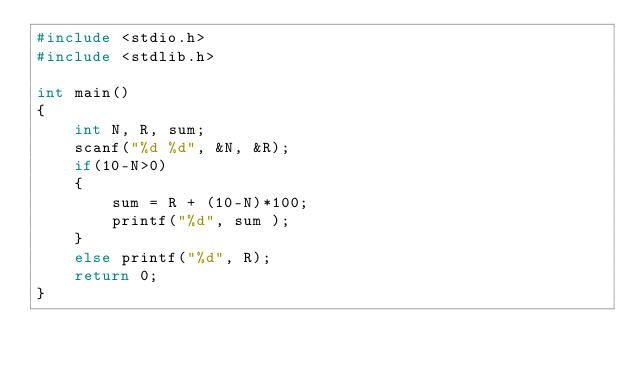<code> <loc_0><loc_0><loc_500><loc_500><_C_>#include <stdio.h>
#include <stdlib.h>

int main()
{
    int N, R, sum;
    scanf("%d %d", &N, &R);
    if(10-N>0)
    {
        sum = R + (10-N)*100;
        printf("%d", sum );
    }
    else printf("%d", R);
    return 0;
}
</code> 